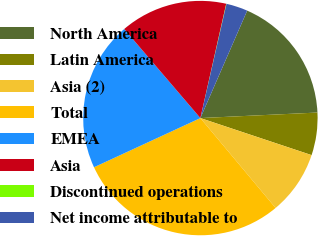Convert chart. <chart><loc_0><loc_0><loc_500><loc_500><pie_chart><fcel>North America<fcel>Latin America<fcel>Asia (2)<fcel>Total<fcel>EMEA<fcel>Asia<fcel>Discontinued operations<fcel>Net income attributable to<nl><fcel>17.71%<fcel>5.87%<fcel>8.79%<fcel>29.2%<fcel>20.63%<fcel>14.8%<fcel>0.04%<fcel>2.96%<nl></chart> 